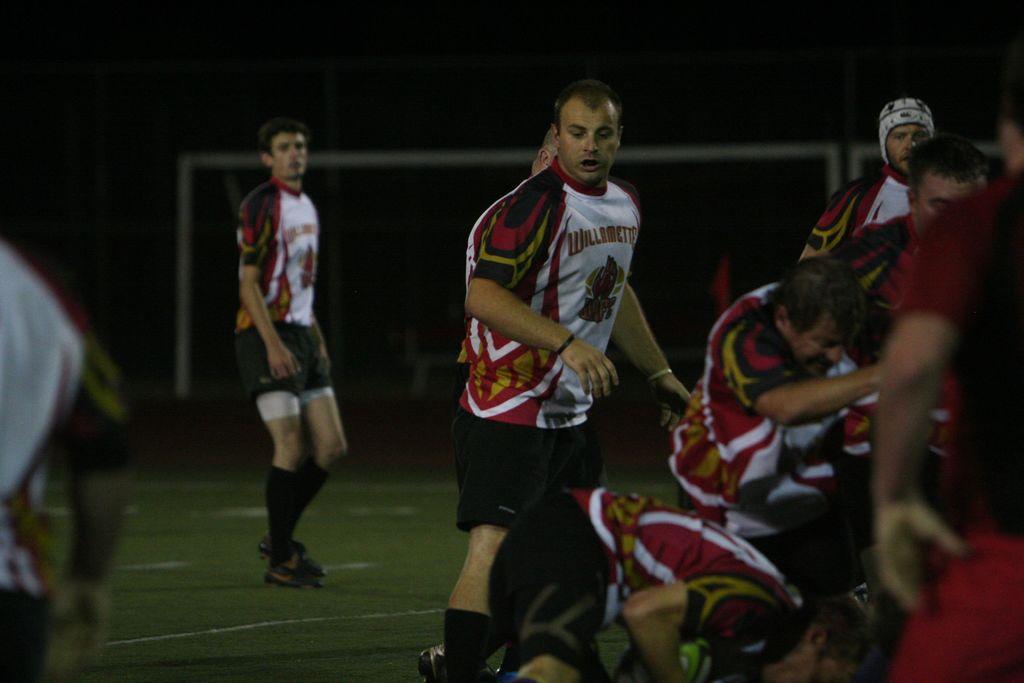What is the team name on the front of the jersey?
Your response must be concise. Willamette. 